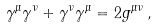Convert formula to latex. <formula><loc_0><loc_0><loc_500><loc_500>\gamma ^ { \mu } \gamma ^ { \nu } + \gamma ^ { \nu } \gamma ^ { \mu } = 2 g ^ { \mu \nu } \, ,</formula> 